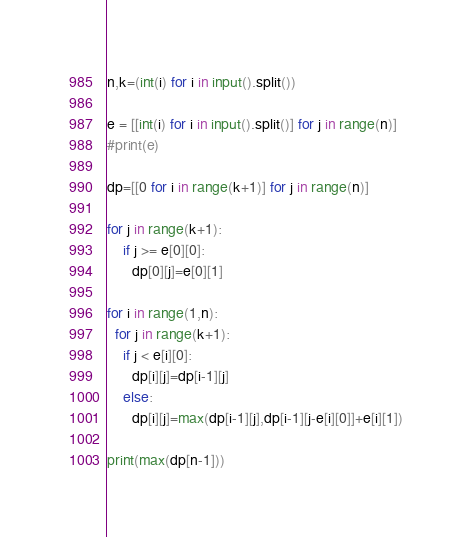Convert code to text. <code><loc_0><loc_0><loc_500><loc_500><_Python_>n,k=(int(i) for i in input().split())

e = [[int(i) for i in input().split()] for j in range(n)]
#print(e)

dp=[[0 for i in range(k+1)] for j in range(n)]

for j in range(k+1):
    if j >= e[0][0]:
      dp[0][j]=e[0][1]

for i in range(1,n):
  for j in range(k+1):
    if j < e[i][0]:
      dp[i][j]=dp[i-1][j]
    else:
      dp[i][j]=max(dp[i-1][j],dp[i-1][j-e[i][0]]+e[i][1])

print(max(dp[n-1]))
</code> 